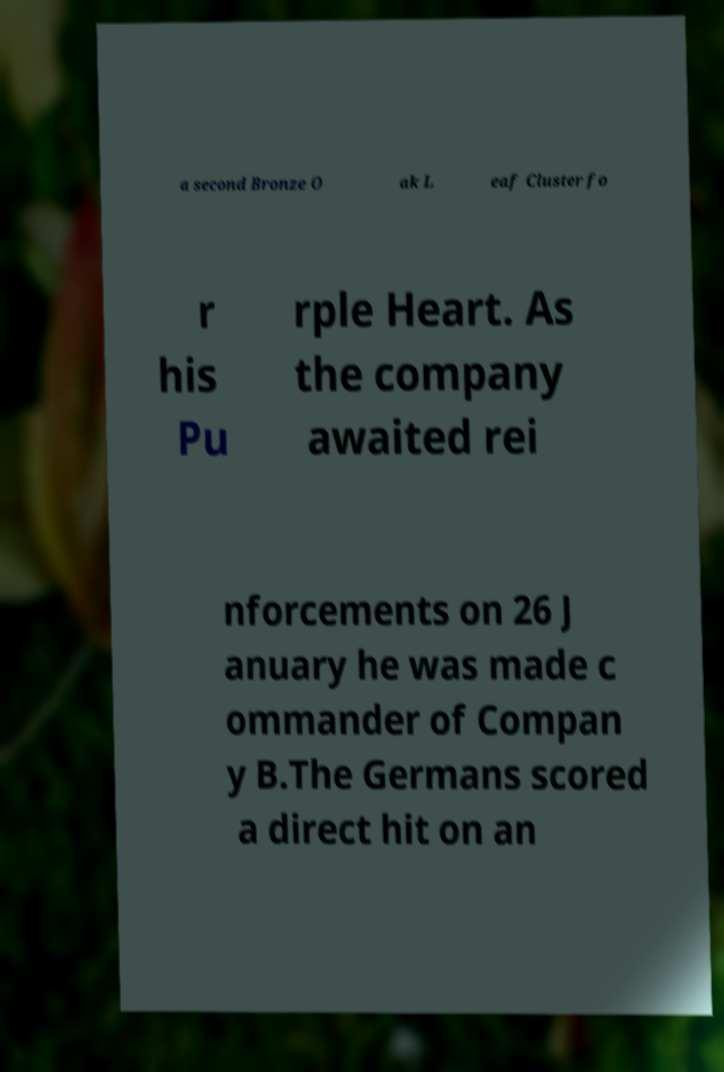For documentation purposes, I need the text within this image transcribed. Could you provide that? a second Bronze O ak L eaf Cluster fo r his Pu rple Heart. As the company awaited rei nforcements on 26 J anuary he was made c ommander of Compan y B.The Germans scored a direct hit on an 